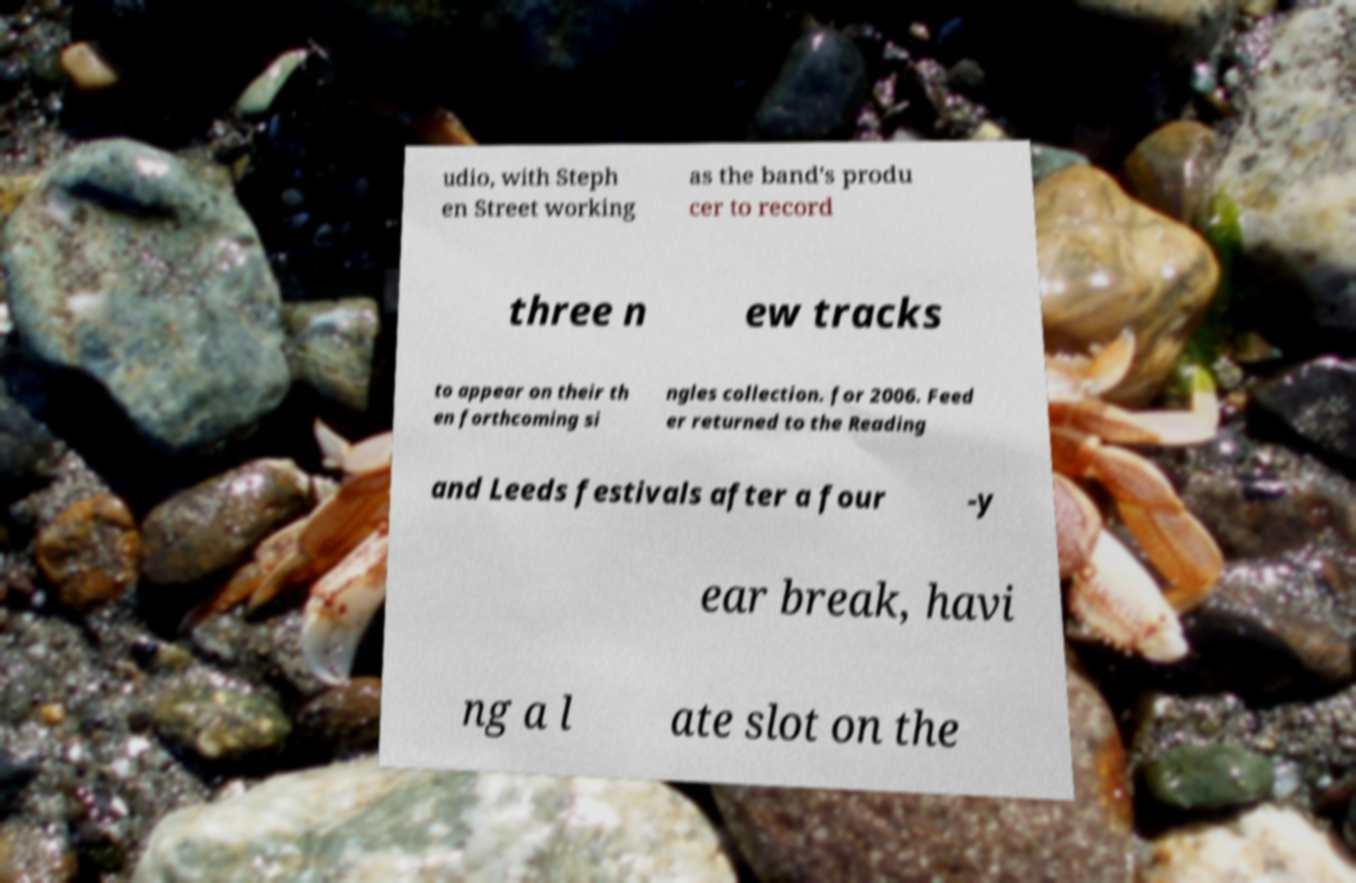Can you read and provide the text displayed in the image?This photo seems to have some interesting text. Can you extract and type it out for me? udio, with Steph en Street working as the band's produ cer to record three n ew tracks to appear on their th en forthcoming si ngles collection. for 2006. Feed er returned to the Reading and Leeds festivals after a four -y ear break, havi ng a l ate slot on the 